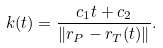Convert formula to latex. <formula><loc_0><loc_0><loc_500><loc_500>k ( t ) = \frac { c _ { 1 } t + c _ { 2 } } { \| r _ { P } - r _ { T } ( t ) \| } .</formula> 